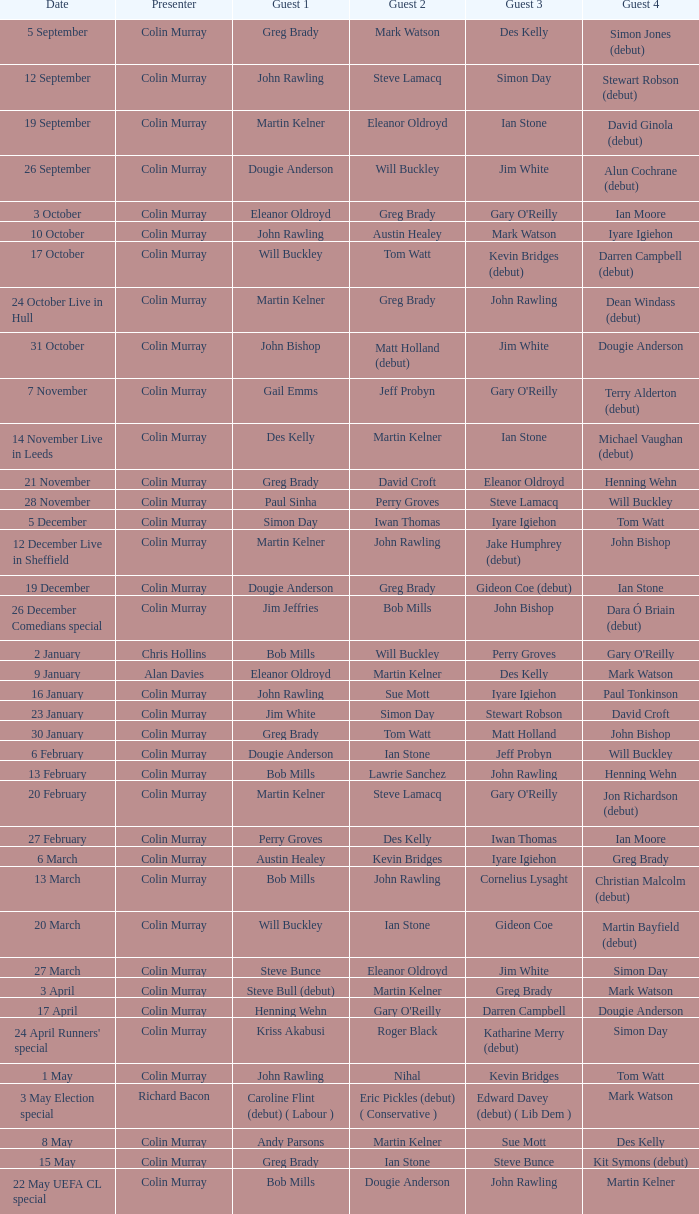On episodes where guest 1 is Jim White, who was guest 3? Stewart Robson. 